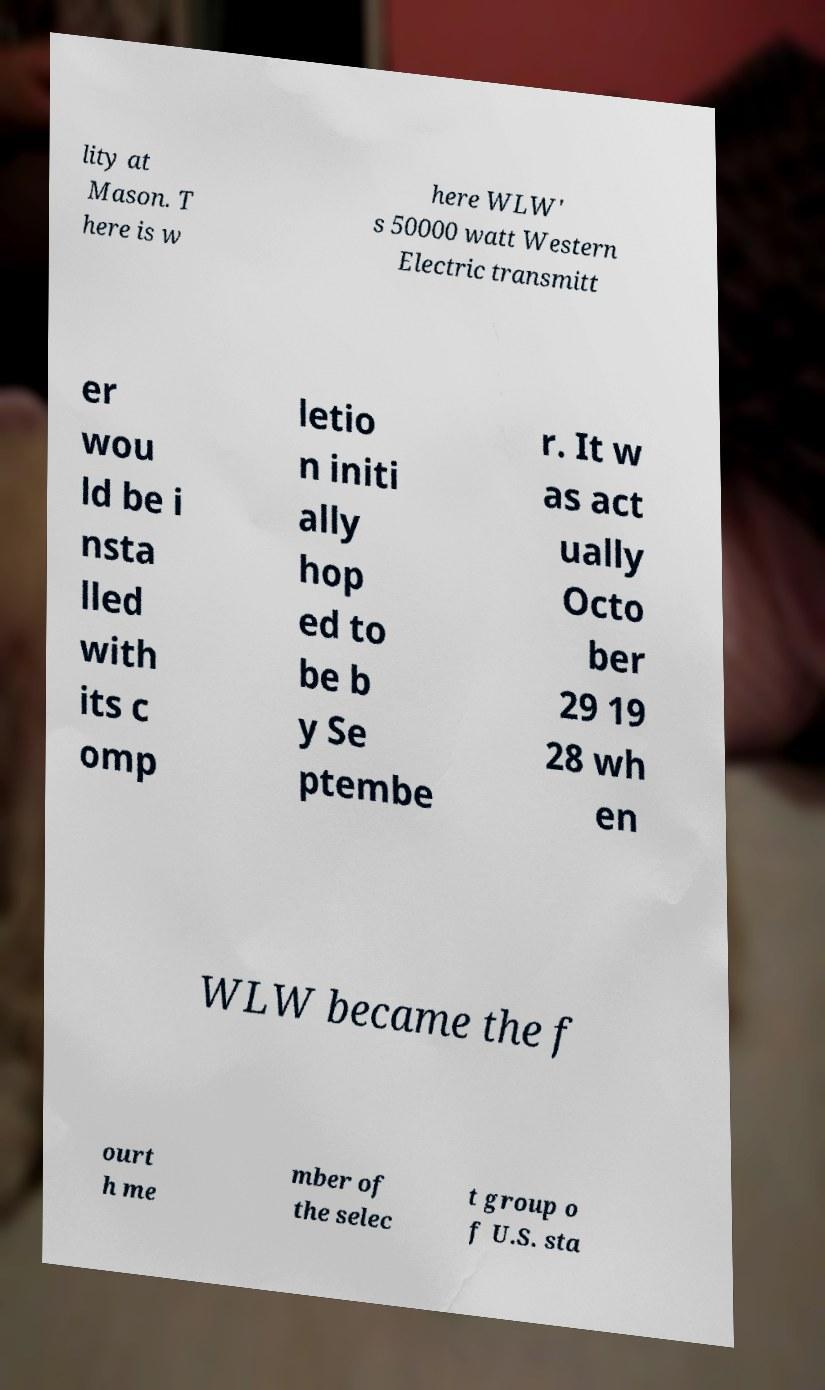Can you accurately transcribe the text from the provided image for me? lity at Mason. T here is w here WLW' s 50000 watt Western Electric transmitt er wou ld be i nsta lled with its c omp letio n initi ally hop ed to be b y Se ptembe r. It w as act ually Octo ber 29 19 28 wh en WLW became the f ourt h me mber of the selec t group o f U.S. sta 